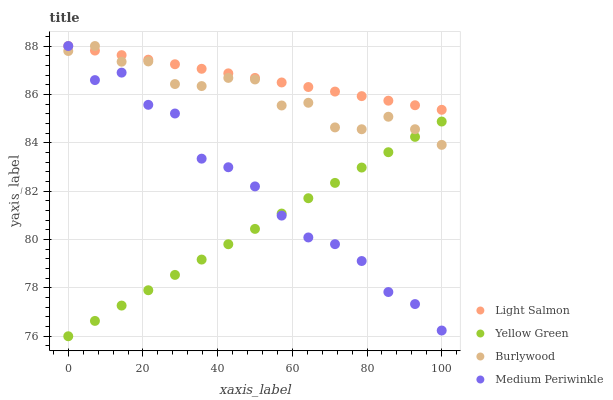Does Yellow Green have the minimum area under the curve?
Answer yes or no. Yes. Does Light Salmon have the maximum area under the curve?
Answer yes or no. Yes. Does Medium Periwinkle have the minimum area under the curve?
Answer yes or no. No. Does Medium Periwinkle have the maximum area under the curve?
Answer yes or no. No. Is Yellow Green the smoothest?
Answer yes or no. Yes. Is Medium Periwinkle the roughest?
Answer yes or no. Yes. Is Light Salmon the smoothest?
Answer yes or no. No. Is Light Salmon the roughest?
Answer yes or no. No. Does Yellow Green have the lowest value?
Answer yes or no. Yes. Does Medium Periwinkle have the lowest value?
Answer yes or no. No. Does Medium Periwinkle have the highest value?
Answer yes or no. Yes. Does Yellow Green have the highest value?
Answer yes or no. No. Is Yellow Green less than Light Salmon?
Answer yes or no. Yes. Is Light Salmon greater than Yellow Green?
Answer yes or no. Yes. Does Medium Periwinkle intersect Burlywood?
Answer yes or no. Yes. Is Medium Periwinkle less than Burlywood?
Answer yes or no. No. Is Medium Periwinkle greater than Burlywood?
Answer yes or no. No. Does Yellow Green intersect Light Salmon?
Answer yes or no. No. 